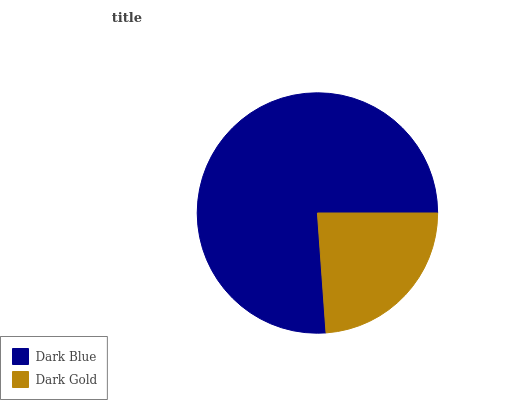Is Dark Gold the minimum?
Answer yes or no. Yes. Is Dark Blue the maximum?
Answer yes or no. Yes. Is Dark Gold the maximum?
Answer yes or no. No. Is Dark Blue greater than Dark Gold?
Answer yes or no. Yes. Is Dark Gold less than Dark Blue?
Answer yes or no. Yes. Is Dark Gold greater than Dark Blue?
Answer yes or no. No. Is Dark Blue less than Dark Gold?
Answer yes or no. No. Is Dark Blue the high median?
Answer yes or no. Yes. Is Dark Gold the low median?
Answer yes or no. Yes. Is Dark Gold the high median?
Answer yes or no. No. Is Dark Blue the low median?
Answer yes or no. No. 